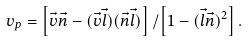Convert formula to latex. <formula><loc_0><loc_0><loc_500><loc_500>v _ { p } = \left [ \vec { v } \vec { n } - ( \vec { v } \vec { l } ) ( \vec { n } \vec { l } ) \right ] / \left [ 1 - ( \vec { l } \vec { n } ) ^ { 2 } \right ] .</formula> 